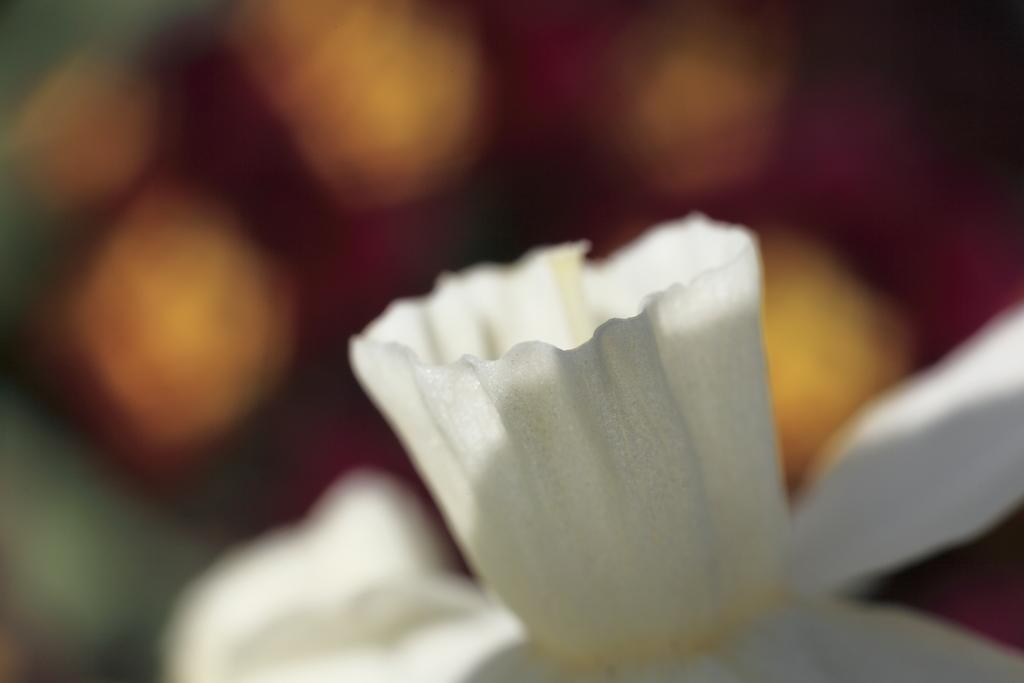Please provide a concise description of this image. This is a zoomed in picture. In the foreground there is a white color object seems to be the flower. The background of the image is blurry. 